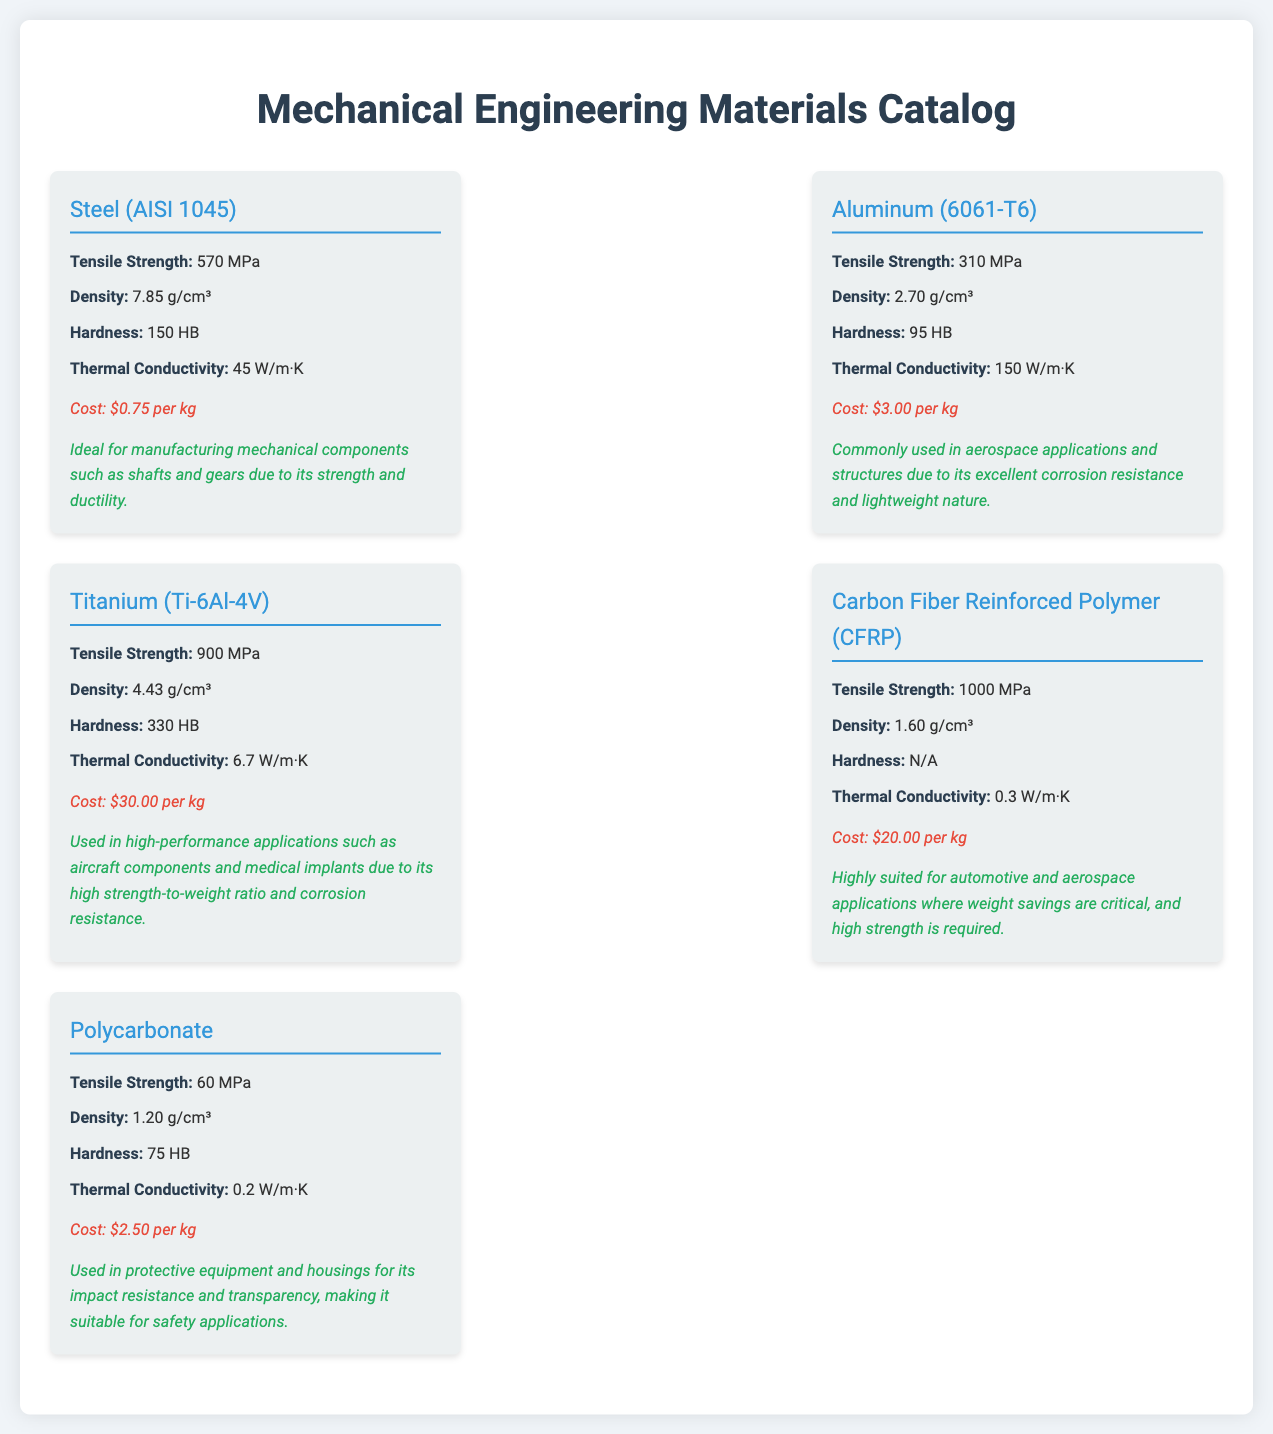what is the tensile strength of Steel (AISI 1045)? The tensile strength of Steel (AISI 1045) is specified in the document as 570 MPa.
Answer: 570 MPa what is the cost of Aluminum (6061-T6)? The document lists the cost of Aluminum (6061-T6) as $3.00 per kg.
Answer: $3.00 per kg which material has the highest tensile strength? By comparing the tensile strengths of all materials in the document, Carbon Fiber Reinforced Polymer (CFRP) is noted to have the highest tensile strength at 1000 MPa.
Answer: Carbon Fiber Reinforced Polymer (CFRP) what is the density of Titanium (Ti-6Al-4V)? The document states that the density of Titanium (Ti-6Al-4V) is 4.43 g/cm³.
Answer: 4.43 g/cm³ what is the primary suitability for Polycarbonate? The document indicates that Polycarbonate is suitable for protective equipment and housings due to its impact resistance and transparency.
Answer: Protective equipment and housings which material is commonly used in aerospace applications? According to the document, Aluminum (6061-T6) is commonly used in aerospace applications due to its corrosion resistance and lightweight nature.
Answer: Aluminum (6061-T6) what is the hardness of Carbon Fiber Reinforced Polymer (CFRP)? The document mentions that the hardness of Carbon Fiber Reinforced Polymer (CFRP) is marked as N/A.
Answer: N/A how does the thermal conductivity of Aluminum (6061-T6) compare to that of Polycarbonate? By examining the properties in the document, Aluminum (6061-T6) has a thermal conductivity of 150 W/m·K, which is significantly higher than Polycarbonate's 0.2 W/m·K.
Answer: Higher what is the density of Carbon Fiber Reinforced Polymer (CFRP)? The document specifies that the density of Carbon Fiber Reinforced Polymer (CFRP) is 1.60 g/cm³.
Answer: 1.60 g/cm³ 